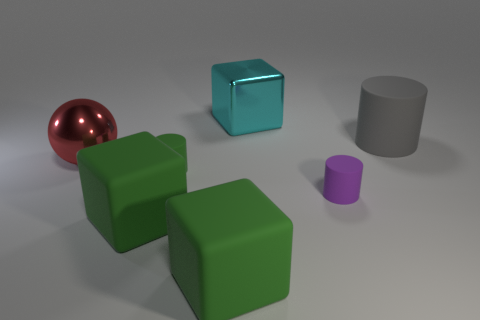What is the material of the small cylinder behind the purple cylinder?
Keep it short and to the point. Rubber. How many big cyan cubes have the same material as the purple thing?
Give a very brief answer. 0. What is the shape of the thing that is both behind the large red metallic ball and in front of the big cyan metallic thing?
Your answer should be very brief. Cylinder. How many things are matte cubes left of the small green cylinder or matte objects to the left of the tiny purple cylinder?
Your response must be concise. 3. Are there the same number of large cylinders that are behind the large gray rubber object and large cyan shiny objects that are to the right of the purple object?
Keep it short and to the point. Yes. The metal thing that is in front of the metal object that is right of the large ball is what shape?
Give a very brief answer. Sphere. Are there any big red things that have the same shape as the tiny green thing?
Give a very brief answer. No. How many big gray things are there?
Your answer should be compact. 1. Is the material of the large object that is on the right side of the shiny cube the same as the large red thing?
Your answer should be compact. No. Are there any cyan things that have the same size as the red thing?
Make the answer very short. Yes. 